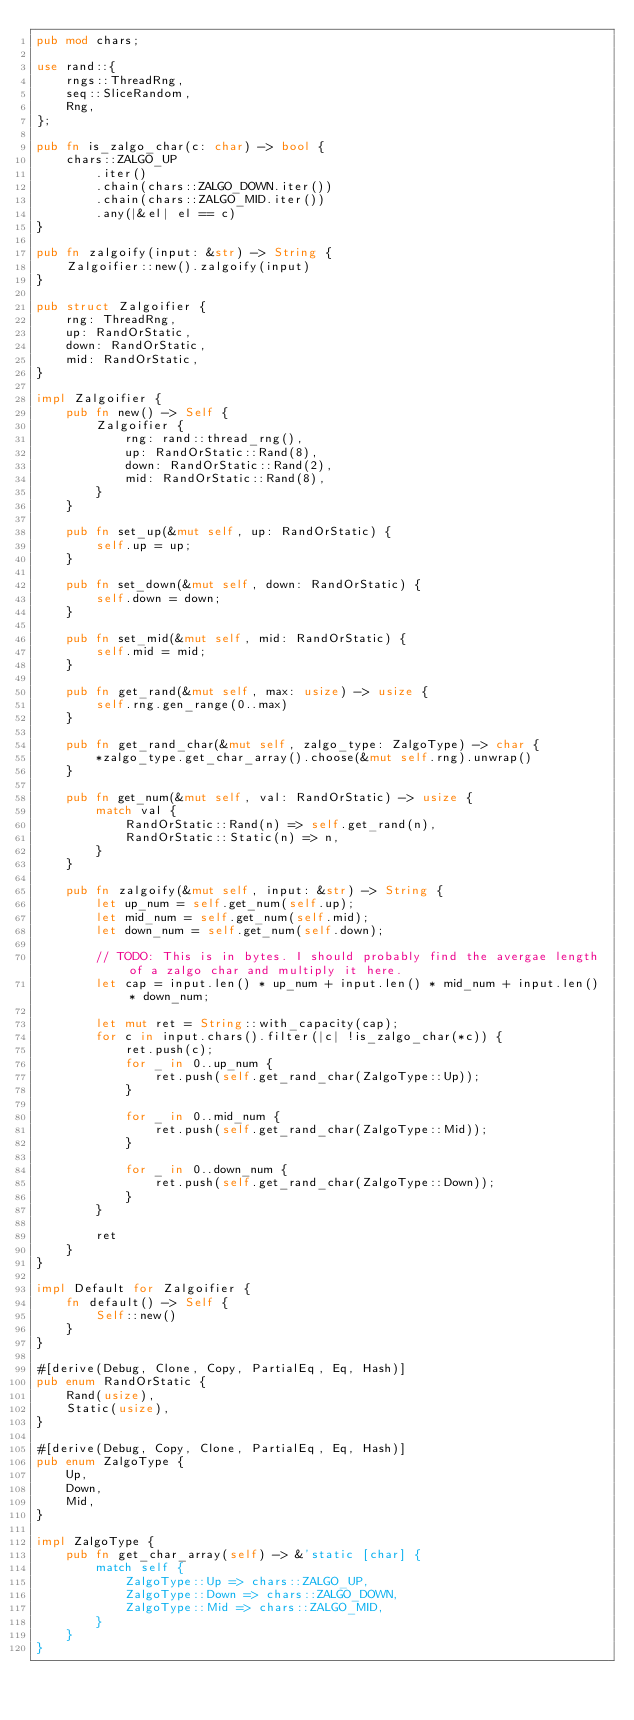Convert code to text. <code><loc_0><loc_0><loc_500><loc_500><_Rust_>pub mod chars;

use rand::{
    rngs::ThreadRng,
    seq::SliceRandom,
    Rng,
};

pub fn is_zalgo_char(c: char) -> bool {
    chars::ZALGO_UP
        .iter()
        .chain(chars::ZALGO_DOWN.iter())
        .chain(chars::ZALGO_MID.iter())
        .any(|&el| el == c)
}

pub fn zalgoify(input: &str) -> String {
    Zalgoifier::new().zalgoify(input)
}

pub struct Zalgoifier {
    rng: ThreadRng,
    up: RandOrStatic,
    down: RandOrStatic,
    mid: RandOrStatic,
}

impl Zalgoifier {
    pub fn new() -> Self {
        Zalgoifier {
            rng: rand::thread_rng(),
            up: RandOrStatic::Rand(8),
            down: RandOrStatic::Rand(2),
            mid: RandOrStatic::Rand(8),
        }
    }

    pub fn set_up(&mut self, up: RandOrStatic) {
        self.up = up;
    }

    pub fn set_down(&mut self, down: RandOrStatic) {
        self.down = down;
    }

    pub fn set_mid(&mut self, mid: RandOrStatic) {
        self.mid = mid;
    }

    pub fn get_rand(&mut self, max: usize) -> usize {
        self.rng.gen_range(0..max)
    }

    pub fn get_rand_char(&mut self, zalgo_type: ZalgoType) -> char {
        *zalgo_type.get_char_array().choose(&mut self.rng).unwrap()
    }

    pub fn get_num(&mut self, val: RandOrStatic) -> usize {
        match val {
            RandOrStatic::Rand(n) => self.get_rand(n),
            RandOrStatic::Static(n) => n,
        }
    }

    pub fn zalgoify(&mut self, input: &str) -> String {
        let up_num = self.get_num(self.up);
        let mid_num = self.get_num(self.mid);
        let down_num = self.get_num(self.down);

        // TODO: This is in bytes. I should probably find the avergae length of a zalgo char and multiply it here.
        let cap = input.len() * up_num + input.len() * mid_num + input.len() * down_num;

        let mut ret = String::with_capacity(cap);
        for c in input.chars().filter(|c| !is_zalgo_char(*c)) {
            ret.push(c);
            for _ in 0..up_num {
                ret.push(self.get_rand_char(ZalgoType::Up));
            }

            for _ in 0..mid_num {
                ret.push(self.get_rand_char(ZalgoType::Mid));
            }

            for _ in 0..down_num {
                ret.push(self.get_rand_char(ZalgoType::Down));
            }
        }

        ret
    }
}

impl Default for Zalgoifier {
    fn default() -> Self {
        Self::new()
    }
}

#[derive(Debug, Clone, Copy, PartialEq, Eq, Hash)]
pub enum RandOrStatic {
    Rand(usize),
    Static(usize),
}

#[derive(Debug, Copy, Clone, PartialEq, Eq, Hash)]
pub enum ZalgoType {
    Up,
    Down,
    Mid,
}

impl ZalgoType {
    pub fn get_char_array(self) -> &'static [char] {
        match self {
            ZalgoType::Up => chars::ZALGO_UP,
            ZalgoType::Down => chars::ZALGO_DOWN,
            ZalgoType::Mid => chars::ZALGO_MID,
        }
    }
}
</code> 